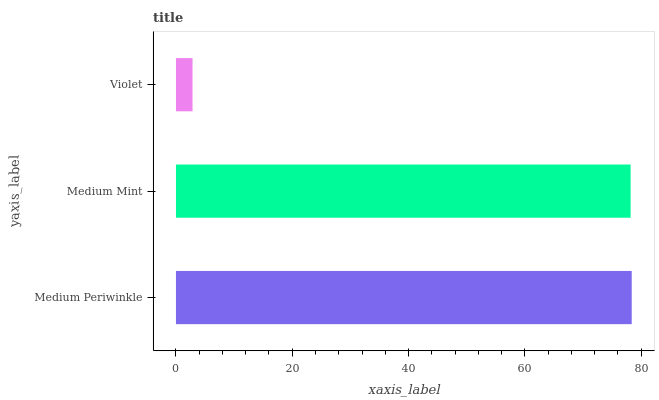Is Violet the minimum?
Answer yes or no. Yes. Is Medium Periwinkle the maximum?
Answer yes or no. Yes. Is Medium Mint the minimum?
Answer yes or no. No. Is Medium Mint the maximum?
Answer yes or no. No. Is Medium Periwinkle greater than Medium Mint?
Answer yes or no. Yes. Is Medium Mint less than Medium Periwinkle?
Answer yes or no. Yes. Is Medium Mint greater than Medium Periwinkle?
Answer yes or no. No. Is Medium Periwinkle less than Medium Mint?
Answer yes or no. No. Is Medium Mint the high median?
Answer yes or no. Yes. Is Medium Mint the low median?
Answer yes or no. Yes. Is Violet the high median?
Answer yes or no. No. Is Medium Periwinkle the low median?
Answer yes or no. No. 